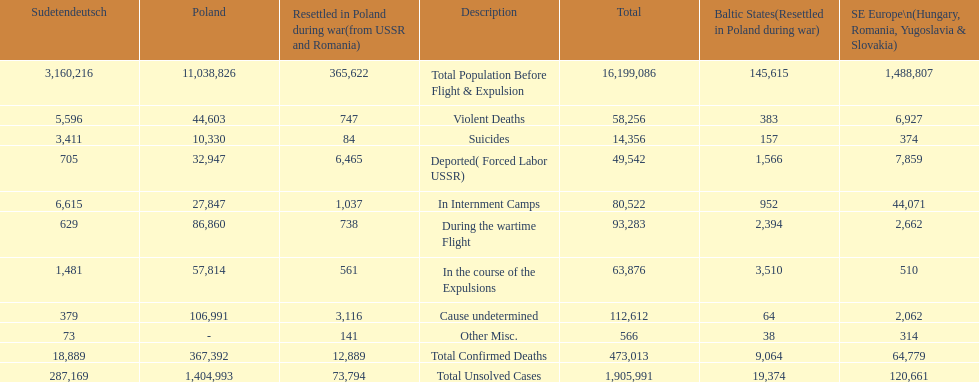How many causes were responsible for more than 50,000 confirmed deaths? 5. 